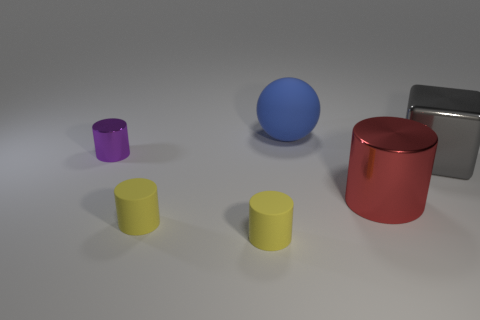There is a blue rubber thing; is it the same size as the metallic cylinder in front of the big gray object?
Provide a short and direct response. Yes. What shape is the object that is behind the large gray thing and left of the blue thing?
Your response must be concise. Cylinder. There is a red cylinder that is made of the same material as the small purple object; what size is it?
Offer a terse response. Large. What number of large spheres are behind the big thing that is behind the small purple thing?
Give a very brief answer. 0. Is the material of the cylinder that is behind the red metallic thing the same as the blue sphere?
Keep it short and to the point. No. Is there anything else that is the same material as the large cylinder?
Provide a short and direct response. Yes. There is a cylinder right of the big object that is behind the big cube; what size is it?
Keep it short and to the point. Large. There is a cylinder that is behind the shiny cylinder in front of the big metallic thing right of the red thing; what is its size?
Offer a terse response. Small. Is the shape of the shiny object to the left of the blue matte sphere the same as the large thing that is in front of the gray metallic thing?
Offer a very short reply. Yes. How many other things are there of the same color as the big metallic cylinder?
Offer a terse response. 0. 